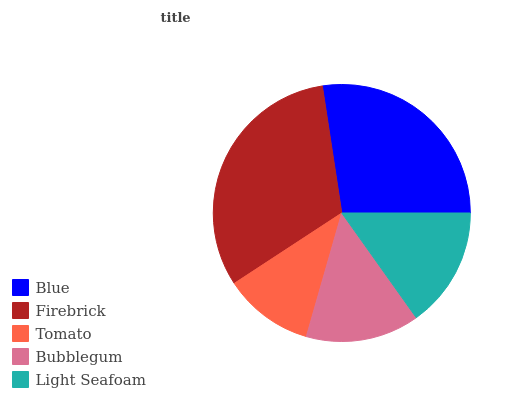Is Tomato the minimum?
Answer yes or no. Yes. Is Firebrick the maximum?
Answer yes or no. Yes. Is Firebrick the minimum?
Answer yes or no. No. Is Tomato the maximum?
Answer yes or no. No. Is Firebrick greater than Tomato?
Answer yes or no. Yes. Is Tomato less than Firebrick?
Answer yes or no. Yes. Is Tomato greater than Firebrick?
Answer yes or no. No. Is Firebrick less than Tomato?
Answer yes or no. No. Is Light Seafoam the high median?
Answer yes or no. Yes. Is Light Seafoam the low median?
Answer yes or no. Yes. Is Tomato the high median?
Answer yes or no. No. Is Firebrick the low median?
Answer yes or no. No. 